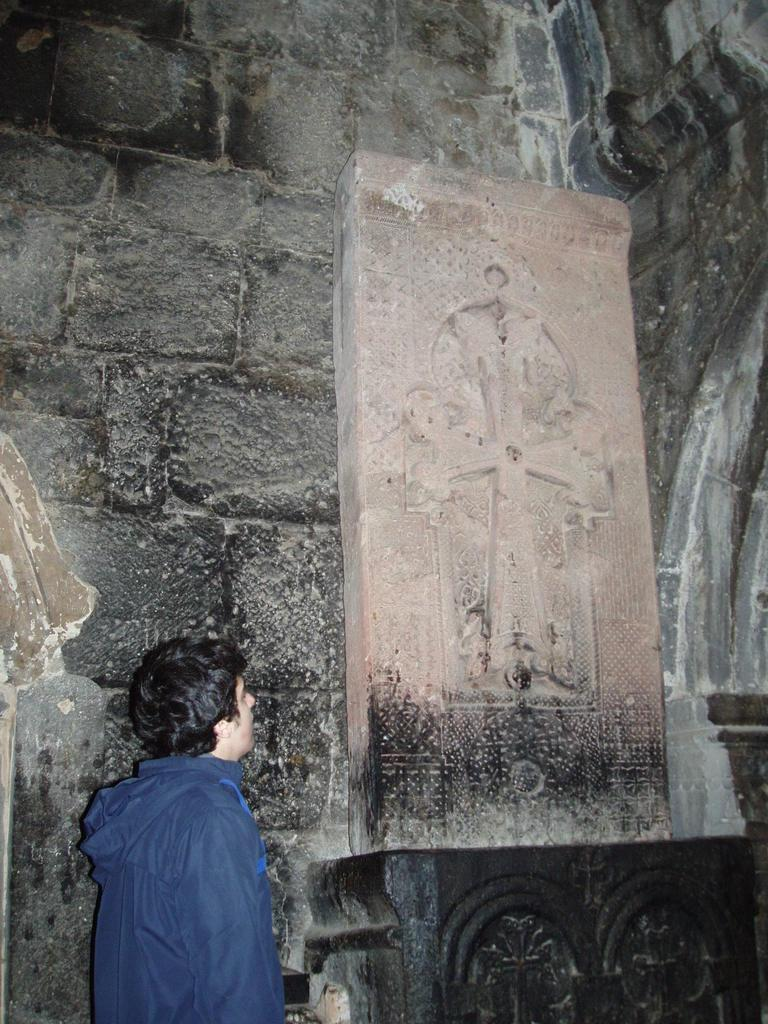Who is present in the image? There is a man in the image. What can be seen on the platform in the image? There is a cemetery on a platform in the image. What is visible in the background of the image? There is a wall visible in the background of the image. What type of cap is the police officer wearing in the image? There is no police officer or cap present in the image. What is the connection between the man and the cemetery in the image? The provided facts do not mention any connection between the man and the cemetery; we can only observe their presence in the image. 